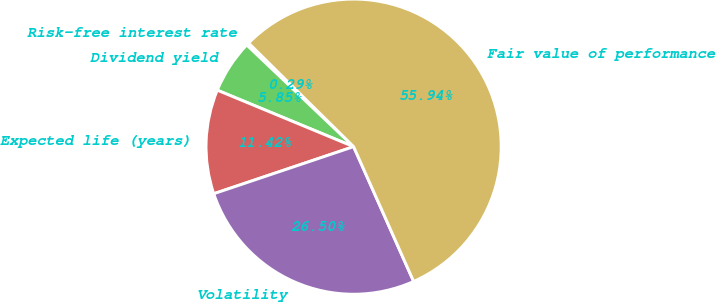Convert chart. <chart><loc_0><loc_0><loc_500><loc_500><pie_chart><fcel>Risk-free interest rate<fcel>Dividend yield<fcel>Expected life (years)<fcel>Volatility<fcel>Fair value of performance<nl><fcel>0.29%<fcel>5.85%<fcel>11.42%<fcel>26.5%<fcel>55.94%<nl></chart> 